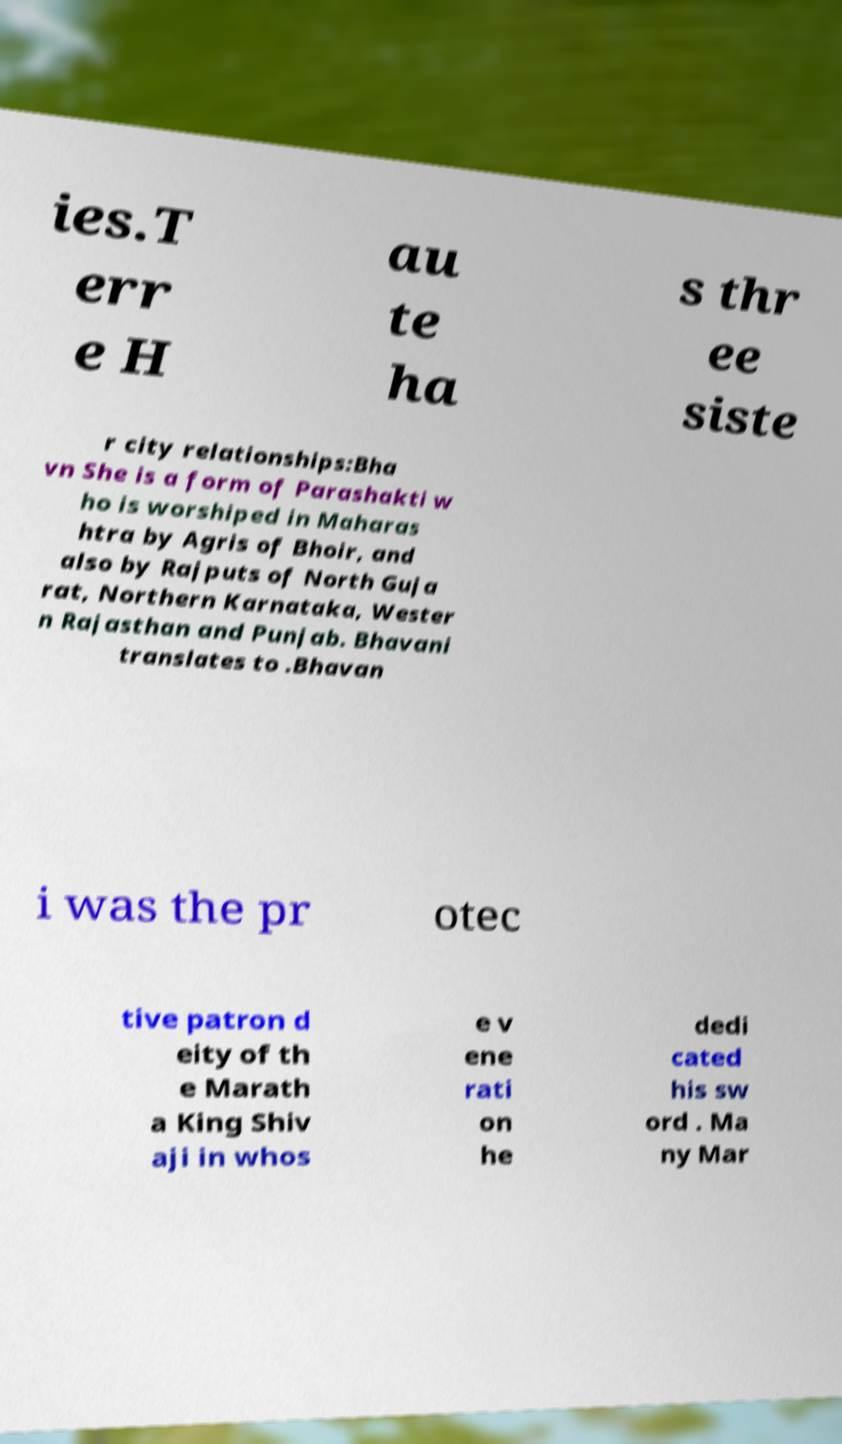Please read and relay the text visible in this image. What does it say? ies.T err e H au te ha s thr ee siste r city relationships:Bha vn She is a form of Parashakti w ho is worshiped in Maharas htra by Agris of Bhoir, and also by Rajputs of North Guja rat, Northern Karnataka, Wester n Rajasthan and Punjab. Bhavani translates to .Bhavan i was the pr otec tive patron d eity of th e Marath a King Shiv aji in whos e v ene rati on he dedi cated his sw ord . Ma ny Mar 